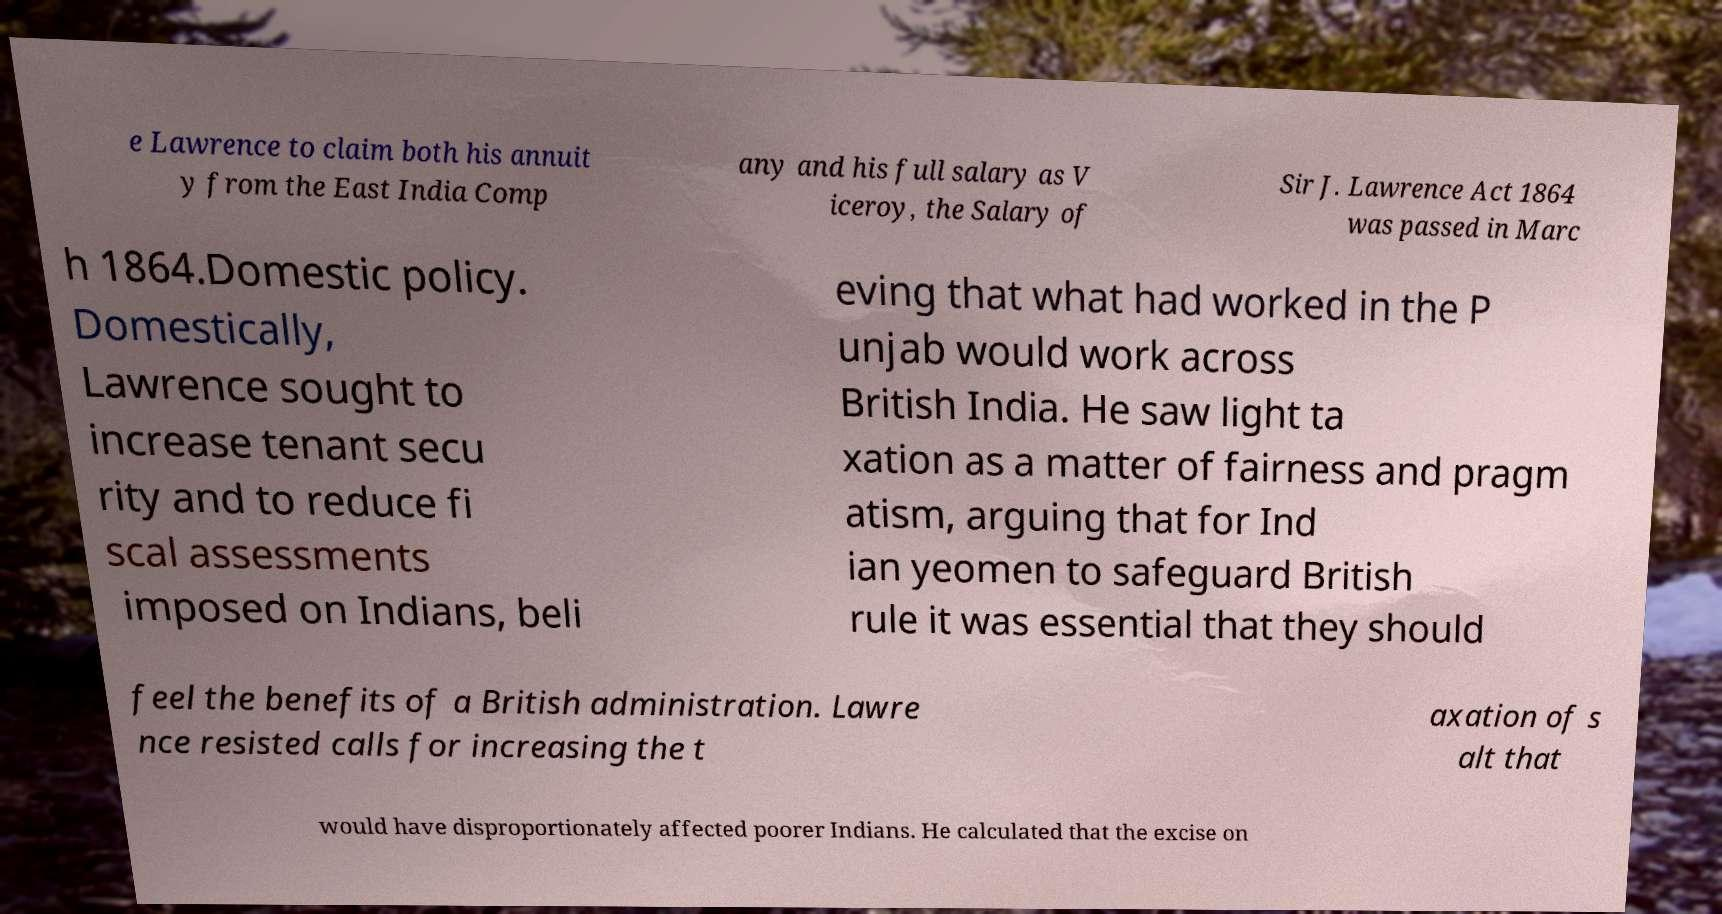Please identify and transcribe the text found in this image. e Lawrence to claim both his annuit y from the East India Comp any and his full salary as V iceroy, the Salary of Sir J. Lawrence Act 1864 was passed in Marc h 1864.Domestic policy. Domestically, Lawrence sought to increase tenant secu rity and to reduce fi scal assessments imposed on Indians, beli eving that what had worked in the P unjab would work across British India. He saw light ta xation as a matter of fairness and pragm atism, arguing that for Ind ian yeomen to safeguard British rule it was essential that they should feel the benefits of a British administration. Lawre nce resisted calls for increasing the t axation of s alt that would have disproportionately affected poorer Indians. He calculated that the excise on 